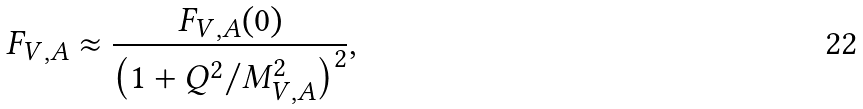Convert formula to latex. <formula><loc_0><loc_0><loc_500><loc_500>F _ { V , A } \approx \frac { F _ { V , A } ( 0 ) } { \left ( 1 + Q ^ { 2 } / M _ { V , A } ^ { 2 } \right ) ^ { 2 } } ,</formula> 